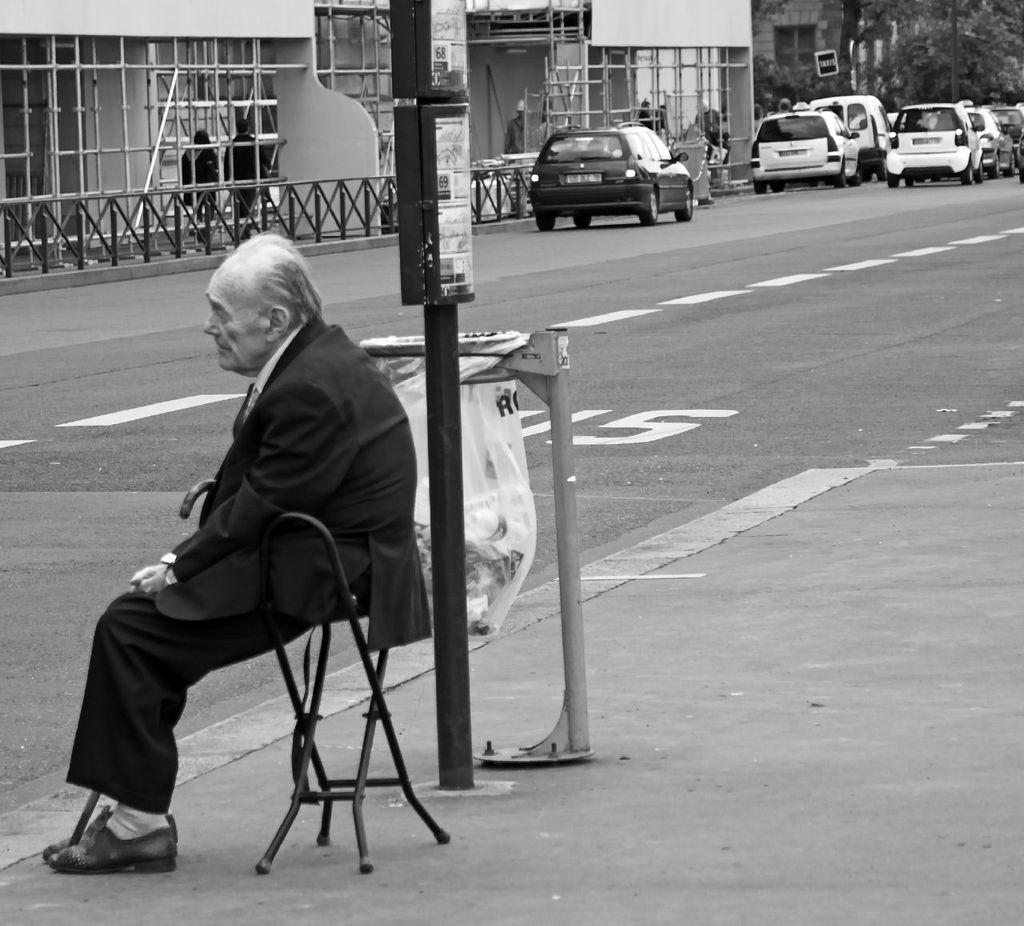Who is the main subject in the image? There is an old man in the image. What is the old man wearing? The old man is wearing a suit. What is the old man doing in the image? The old man is sitting in a chair. What can be seen in the background of the image? There are cars on the road behind him. What type of letter is the old man holding in the image? There is no letter present in the image; the old man is not holding anything. What game is the old man playing in the image? There is no game being played in the image; the old man is sitting in a chair. 